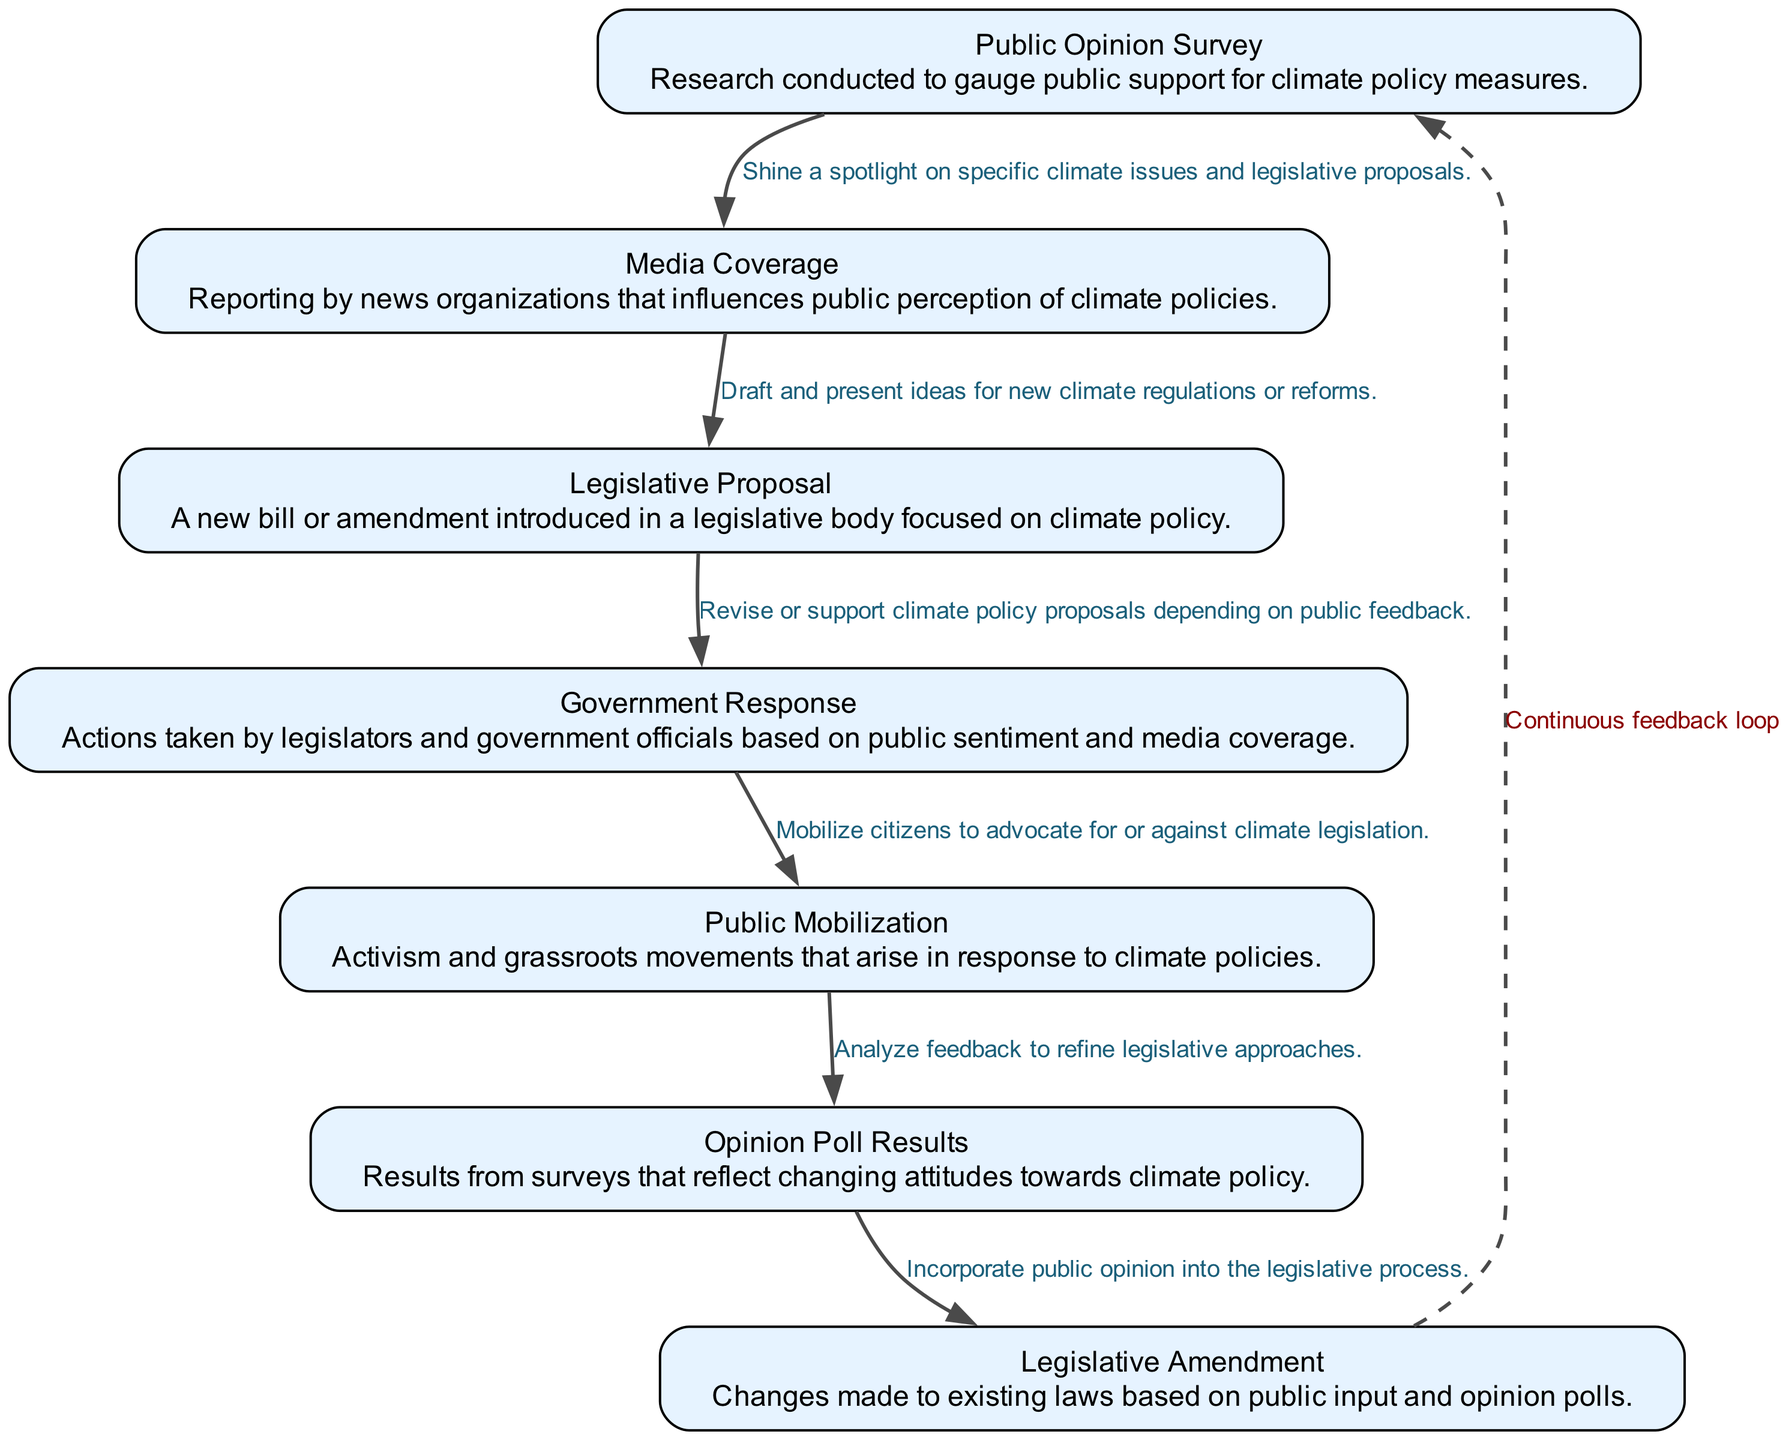What is the first element in the diagram? The first element listed in the diagram is "Public Opinion Survey," which is also the starting point of the flow.
Answer: Public Opinion Survey How many nodes are in the feedback loop? There are seven elements shown in the diagram, each representing a node, creating a continuous feedback loop.
Answer: Seven What action follows Media Coverage? According to the flow, Media Coverage leads to the Legislative Proposal, which is the next action in the sequence.
Answer: Legislative Proposal How does Public Mobilization influence legislation? Public Mobilization can lead to Government Response as legislators may adjust policies based on grassroots activism and public advocacy reflected in the diagram.
Answer: Government Response What is the final step in the feedback loop before it returns to the beginning? The last action before returning to the start of the loop is the "Legislative Amendment," reflecting changes made based on public feedback.
Answer: Legislative Amendment Which element is influenced by Opinion Poll Results? The Legislative Amendment is directly influenced by analyzing the Opinion Poll Results, suggesting that amendments are informed by the feedback received from public opinion.
Answer: Legislative Amendment What is indicated by the dashed line in the diagram? The dashed line indicates a continuous feedback loop, symbolizing that opinions and policies are regularly interconnected and can influence one another over time.
Answer: Continuous feedback loop 